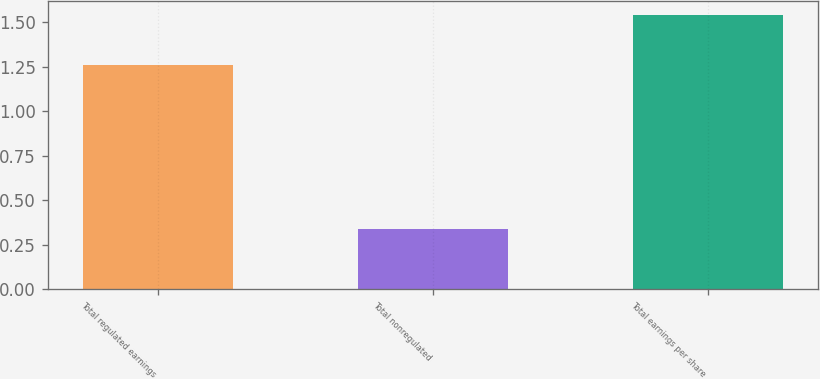Convert chart. <chart><loc_0><loc_0><loc_500><loc_500><bar_chart><fcel>Total regulated earnings<fcel>Total nonregulated<fcel>Total earnings per share<nl><fcel>1.26<fcel>0.34<fcel>1.54<nl></chart> 